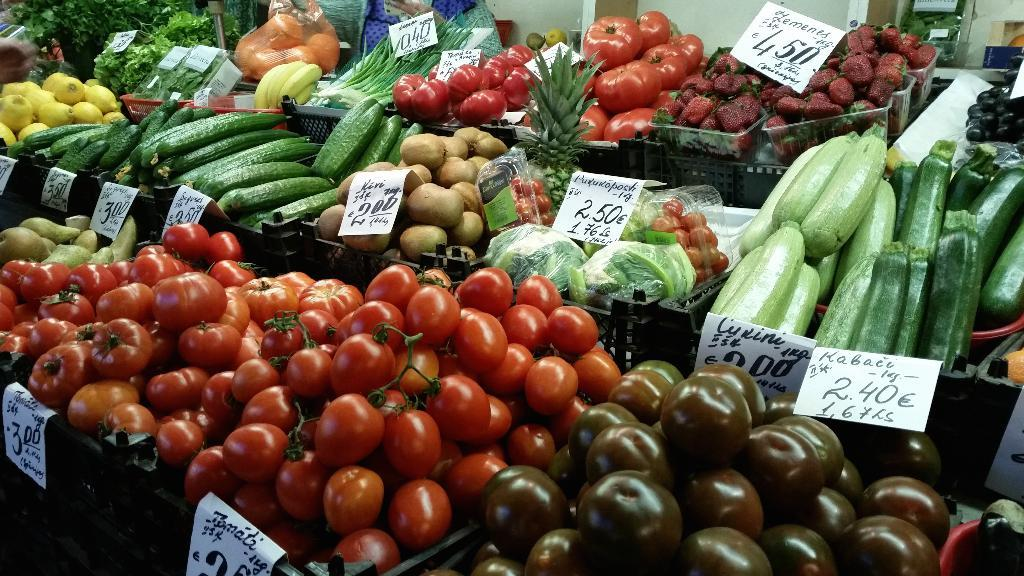What types of fruits and vegetables are visible in the image? There are tomatoes, potatoes, bananas, other fruits, and other vegetables in the image. How are the fruits and vegetables arranged in the image? The items are arranged in baskets. What is associated with the baskets in the image? There are cards associated with the baskets. What can be seen in the background of the image? There is a wall and other objects in the background of the image. What type of face can be seen on the potatoes in the image? There are no faces visible on the potatoes in the image. What town is depicted in the background of the image? There is no town depicted in the background of the image; only a wall and other objects are visible. 